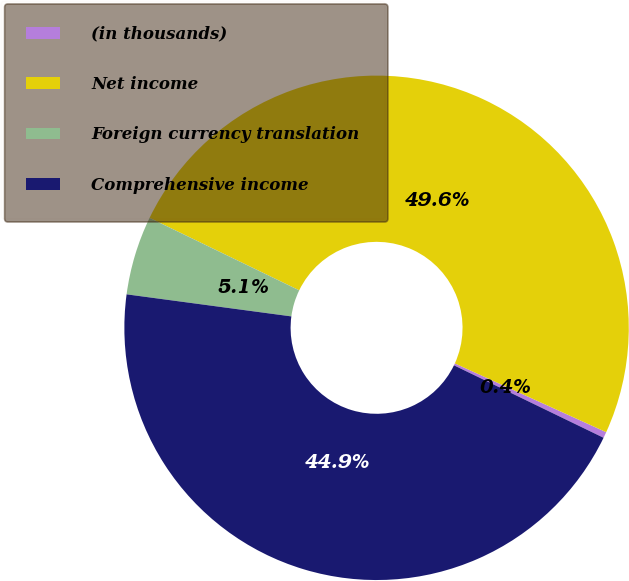Convert chart. <chart><loc_0><loc_0><loc_500><loc_500><pie_chart><fcel>(in thousands)<fcel>Net income<fcel>Foreign currency translation<fcel>Comprehensive income<nl><fcel>0.39%<fcel>49.61%<fcel>5.06%<fcel>44.94%<nl></chart> 